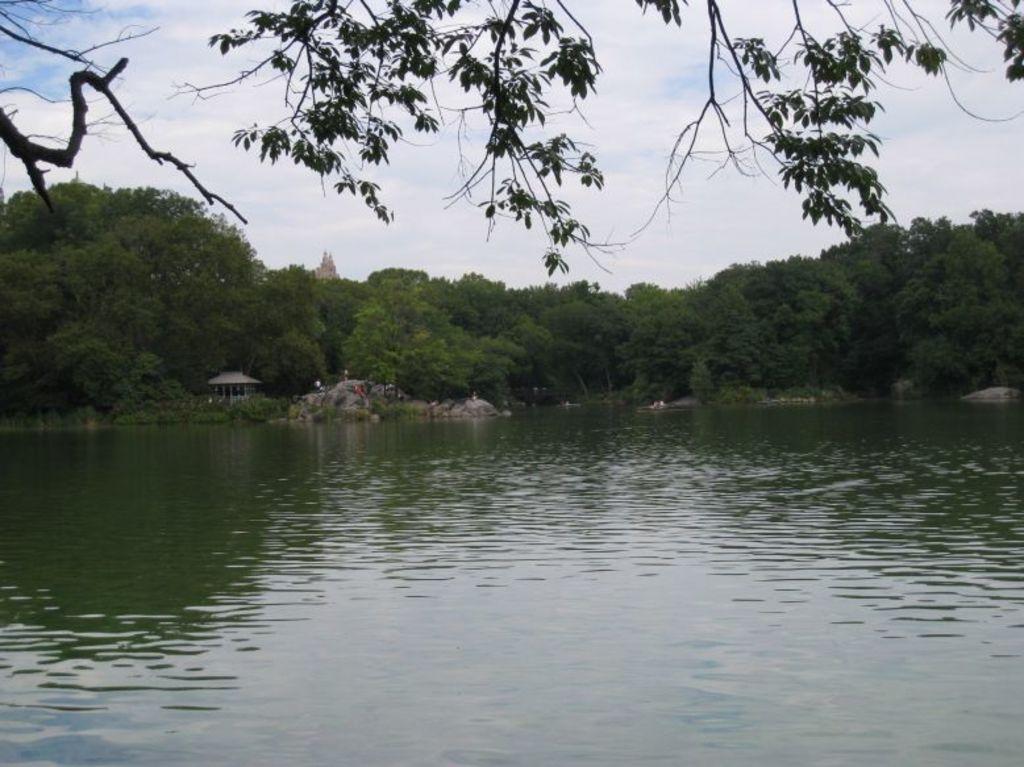How would you summarize this image in a sentence or two? In this image we can see some trees, there is a temple, also we can see the sky, and the river. 